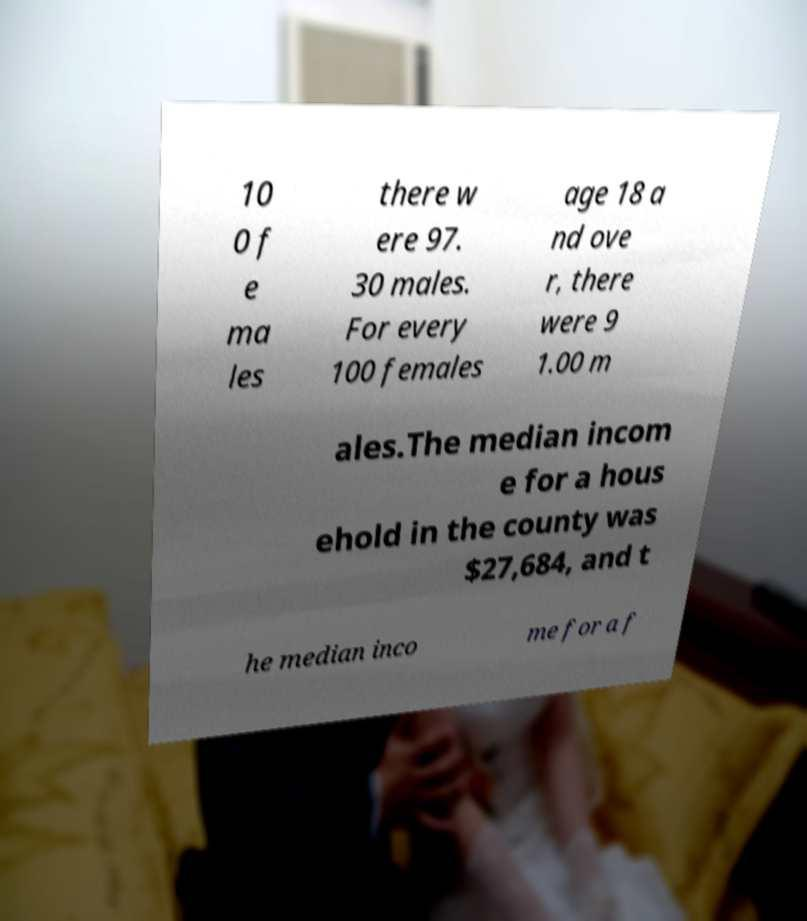For documentation purposes, I need the text within this image transcribed. Could you provide that? 10 0 f e ma les there w ere 97. 30 males. For every 100 females age 18 a nd ove r, there were 9 1.00 m ales.The median incom e for a hous ehold in the county was $27,684, and t he median inco me for a f 